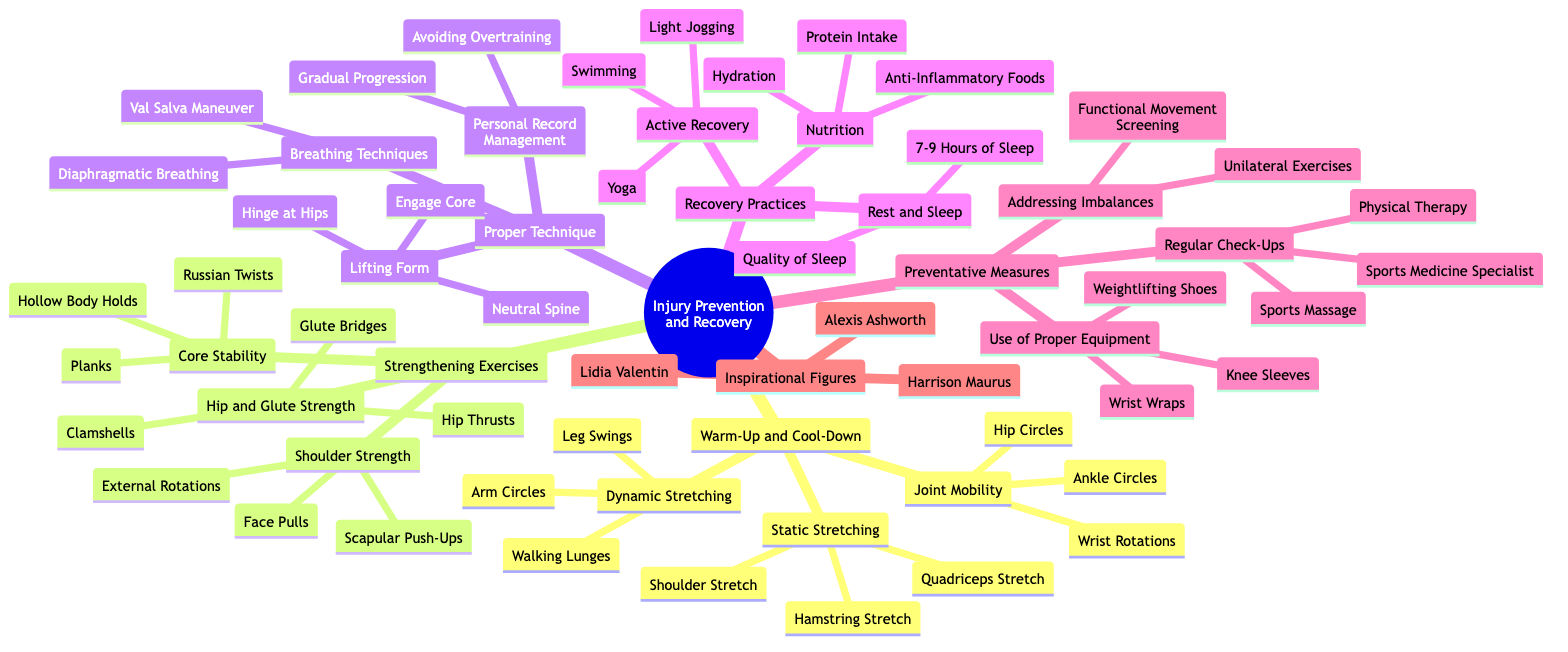What are the three types of stretching in Warm-Up and Cool-Down? The Warm-Up and Cool-Down section of the diagram lists three types of stretching: Dynamic Stretching, Static Stretching, and Joint Mobility. These are specific nodes under the broader category.
Answer: Dynamic Stretching, Static Stretching, Joint Mobility How many exercises are listed under Strengthening Exercises for Shoulder Strength? In the diagram's Strengthening Exercises section, there are three exercises specifically listed under Shoulder Strength: Face Pulls, Scapular Push-Ups, and External Rotations with Resistance Bands. Hence, the count is three.
Answer: 3 Which recovery practice involves quality and quantity of sleep? The Recovery Practices section outlines Rest and Sleep, which includes two key aspects: 7-9 Hours of Sleep and Quality of Sleep. So, this recovery practice is focused on sleep specifics.
Answer: Rest and Sleep What is one technique mentioned under Proper Technique for lifting form? The Proper Technique section includes several techniques related to lifting form, one of which is "Neutral Spine." This indicates a correct posture to maintain while lifting.
Answer: Neutral Spine Which category includes Active Recovery? Active Recovery is specifically listed as part of the Recovery Practices category. This means it's focused on techniques to help recover after workouts.
Answer: Recovery Practices What are the goals of Addressing Imbalances? Under Preventative Measures, Addressing Imbalances consists of two approaches: Unilateral Exercises and Functional Movement Screening. These aim at preventing injuries by assessing and correcting movement imbalances.
Answer: Unilateral Exercises, Functional Movement Screening Who is one of the inspirational figures mentioned in the diagram? The diagram lists several inspirational figures under a dedicated section, one of whom is Alexis Ashworth. She is noted for her achievements in sports.
Answer: Alexis Ashworth What type of exercises are included for Core Stability? The Strengthening Exercises section identifies Planks, Russian Twists, and Hollow Body Holds as exercises specifically for Core Stability, which focus on strengthening the core muscles.
Answer: Planks, Russian Twists, Hollow Body Holds 